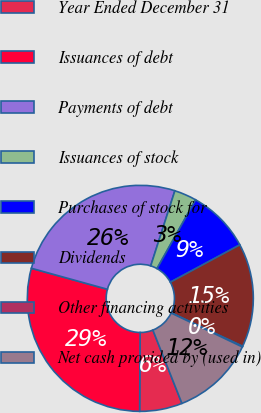Convert chart. <chart><loc_0><loc_0><loc_500><loc_500><pie_chart><fcel>Year Ended December 31<fcel>Issuances of debt<fcel>Payments of debt<fcel>Issuances of stock<fcel>Purchases of stock for<fcel>Dividends<fcel>Other financing activities<fcel>Net cash provided by (used in)<nl><fcel>6.1%<fcel>29.2%<fcel>25.66%<fcel>3.19%<fcel>9.01%<fcel>14.83%<fcel>0.1%<fcel>11.92%<nl></chart> 